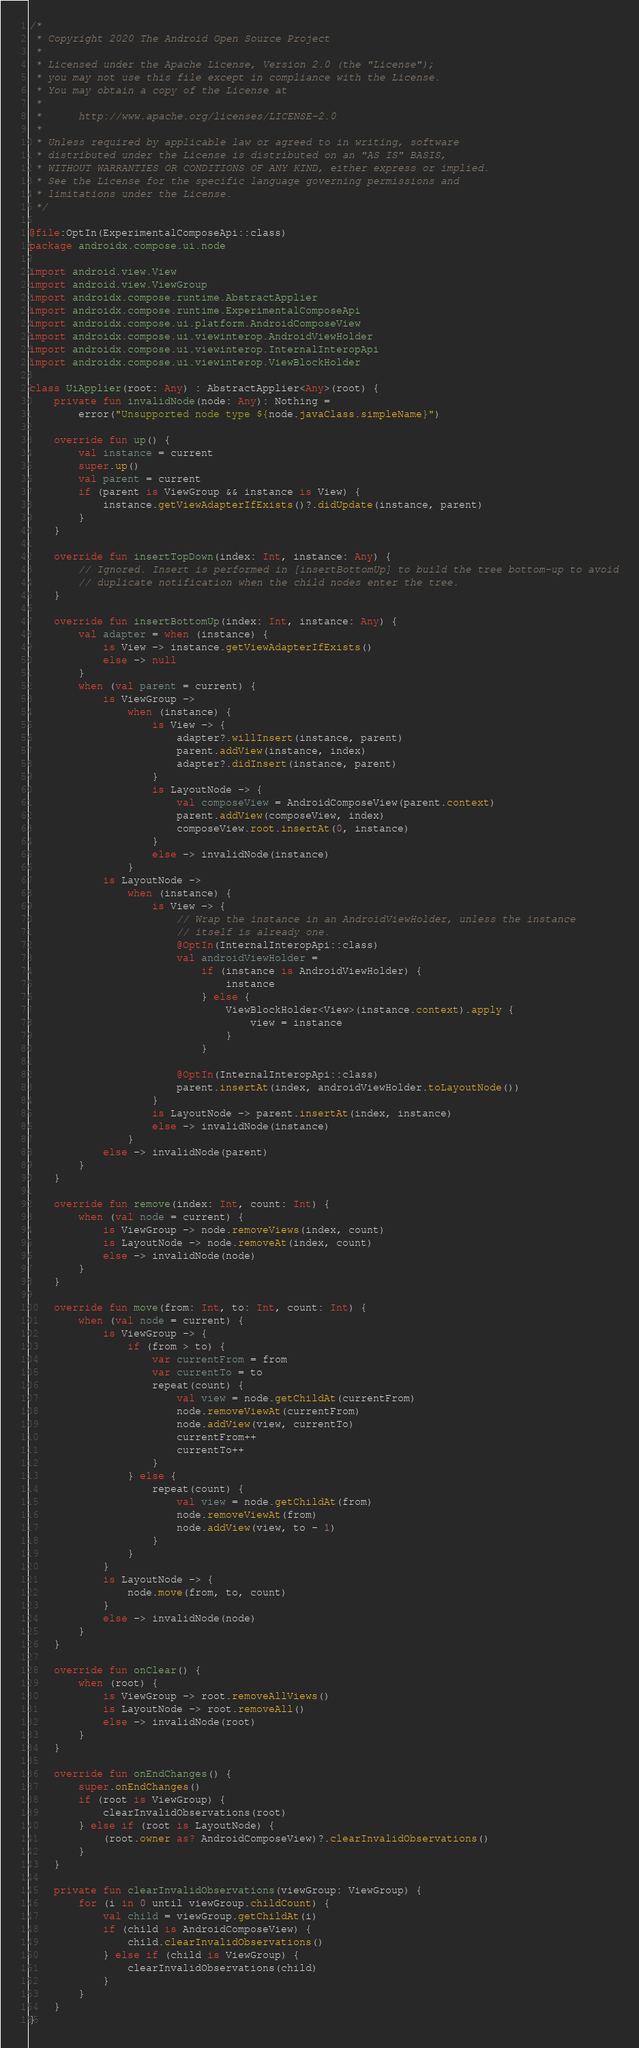Convert code to text. <code><loc_0><loc_0><loc_500><loc_500><_Kotlin_>/*
 * Copyright 2020 The Android Open Source Project
 *
 * Licensed under the Apache License, Version 2.0 (the "License");
 * you may not use this file except in compliance with the License.
 * You may obtain a copy of the License at
 *
 *      http://www.apache.org/licenses/LICENSE-2.0
 *
 * Unless required by applicable law or agreed to in writing, software
 * distributed under the License is distributed on an "AS IS" BASIS,
 * WITHOUT WARRANTIES OR CONDITIONS OF ANY KIND, either express or implied.
 * See the License for the specific language governing permissions and
 * limitations under the License.
 */

@file:OptIn(ExperimentalComposeApi::class)
package androidx.compose.ui.node

import android.view.View
import android.view.ViewGroup
import androidx.compose.runtime.AbstractApplier
import androidx.compose.runtime.ExperimentalComposeApi
import androidx.compose.ui.platform.AndroidComposeView
import androidx.compose.ui.viewinterop.AndroidViewHolder
import androidx.compose.ui.viewinterop.InternalInteropApi
import androidx.compose.ui.viewinterop.ViewBlockHolder

class UiApplier(root: Any) : AbstractApplier<Any>(root) {
    private fun invalidNode(node: Any): Nothing =
        error("Unsupported node type ${node.javaClass.simpleName}")

    override fun up() {
        val instance = current
        super.up()
        val parent = current
        if (parent is ViewGroup && instance is View) {
            instance.getViewAdapterIfExists()?.didUpdate(instance, parent)
        }
    }

    override fun insertTopDown(index: Int, instance: Any) {
        // Ignored. Insert is performed in [insertBottomUp] to build the tree bottom-up to avoid
        // duplicate notification when the child nodes enter the tree.
    }

    override fun insertBottomUp(index: Int, instance: Any) {
        val adapter = when (instance) {
            is View -> instance.getViewAdapterIfExists()
            else -> null
        }
        when (val parent = current) {
            is ViewGroup ->
                when (instance) {
                    is View -> {
                        adapter?.willInsert(instance, parent)
                        parent.addView(instance, index)
                        adapter?.didInsert(instance, parent)
                    }
                    is LayoutNode -> {
                        val composeView = AndroidComposeView(parent.context)
                        parent.addView(composeView, index)
                        composeView.root.insertAt(0, instance)
                    }
                    else -> invalidNode(instance)
                }
            is LayoutNode ->
                when (instance) {
                    is View -> {
                        // Wrap the instance in an AndroidViewHolder, unless the instance
                        // itself is already one.
                        @OptIn(InternalInteropApi::class)
                        val androidViewHolder =
                            if (instance is AndroidViewHolder) {
                                instance
                            } else {
                                ViewBlockHolder<View>(instance.context).apply {
                                    view = instance
                                }
                            }

                        @OptIn(InternalInteropApi::class)
                        parent.insertAt(index, androidViewHolder.toLayoutNode())
                    }
                    is LayoutNode -> parent.insertAt(index, instance)
                    else -> invalidNode(instance)
                }
            else -> invalidNode(parent)
        }
    }

    override fun remove(index: Int, count: Int) {
        when (val node = current) {
            is ViewGroup -> node.removeViews(index, count)
            is LayoutNode -> node.removeAt(index, count)
            else -> invalidNode(node)
        }
    }

    override fun move(from: Int, to: Int, count: Int) {
        when (val node = current) {
            is ViewGroup -> {
                if (from > to) {
                    var currentFrom = from
                    var currentTo = to
                    repeat(count) {
                        val view = node.getChildAt(currentFrom)
                        node.removeViewAt(currentFrom)
                        node.addView(view, currentTo)
                        currentFrom++
                        currentTo++
                    }
                } else {
                    repeat(count) {
                        val view = node.getChildAt(from)
                        node.removeViewAt(from)
                        node.addView(view, to - 1)
                    }
                }
            }
            is LayoutNode -> {
                node.move(from, to, count)
            }
            else -> invalidNode(node)
        }
    }

    override fun onClear() {
        when (root) {
            is ViewGroup -> root.removeAllViews()
            is LayoutNode -> root.removeAll()
            else -> invalidNode(root)
        }
    }

    override fun onEndChanges() {
        super.onEndChanges()
        if (root is ViewGroup) {
            clearInvalidObservations(root)
        } else if (root is LayoutNode) {
            (root.owner as? AndroidComposeView)?.clearInvalidObservations()
        }
    }

    private fun clearInvalidObservations(viewGroup: ViewGroup) {
        for (i in 0 until viewGroup.childCount) {
            val child = viewGroup.getChildAt(i)
            if (child is AndroidComposeView) {
                child.clearInvalidObservations()
            } else if (child is ViewGroup) {
                clearInvalidObservations(child)
            }
        }
    }
}</code> 